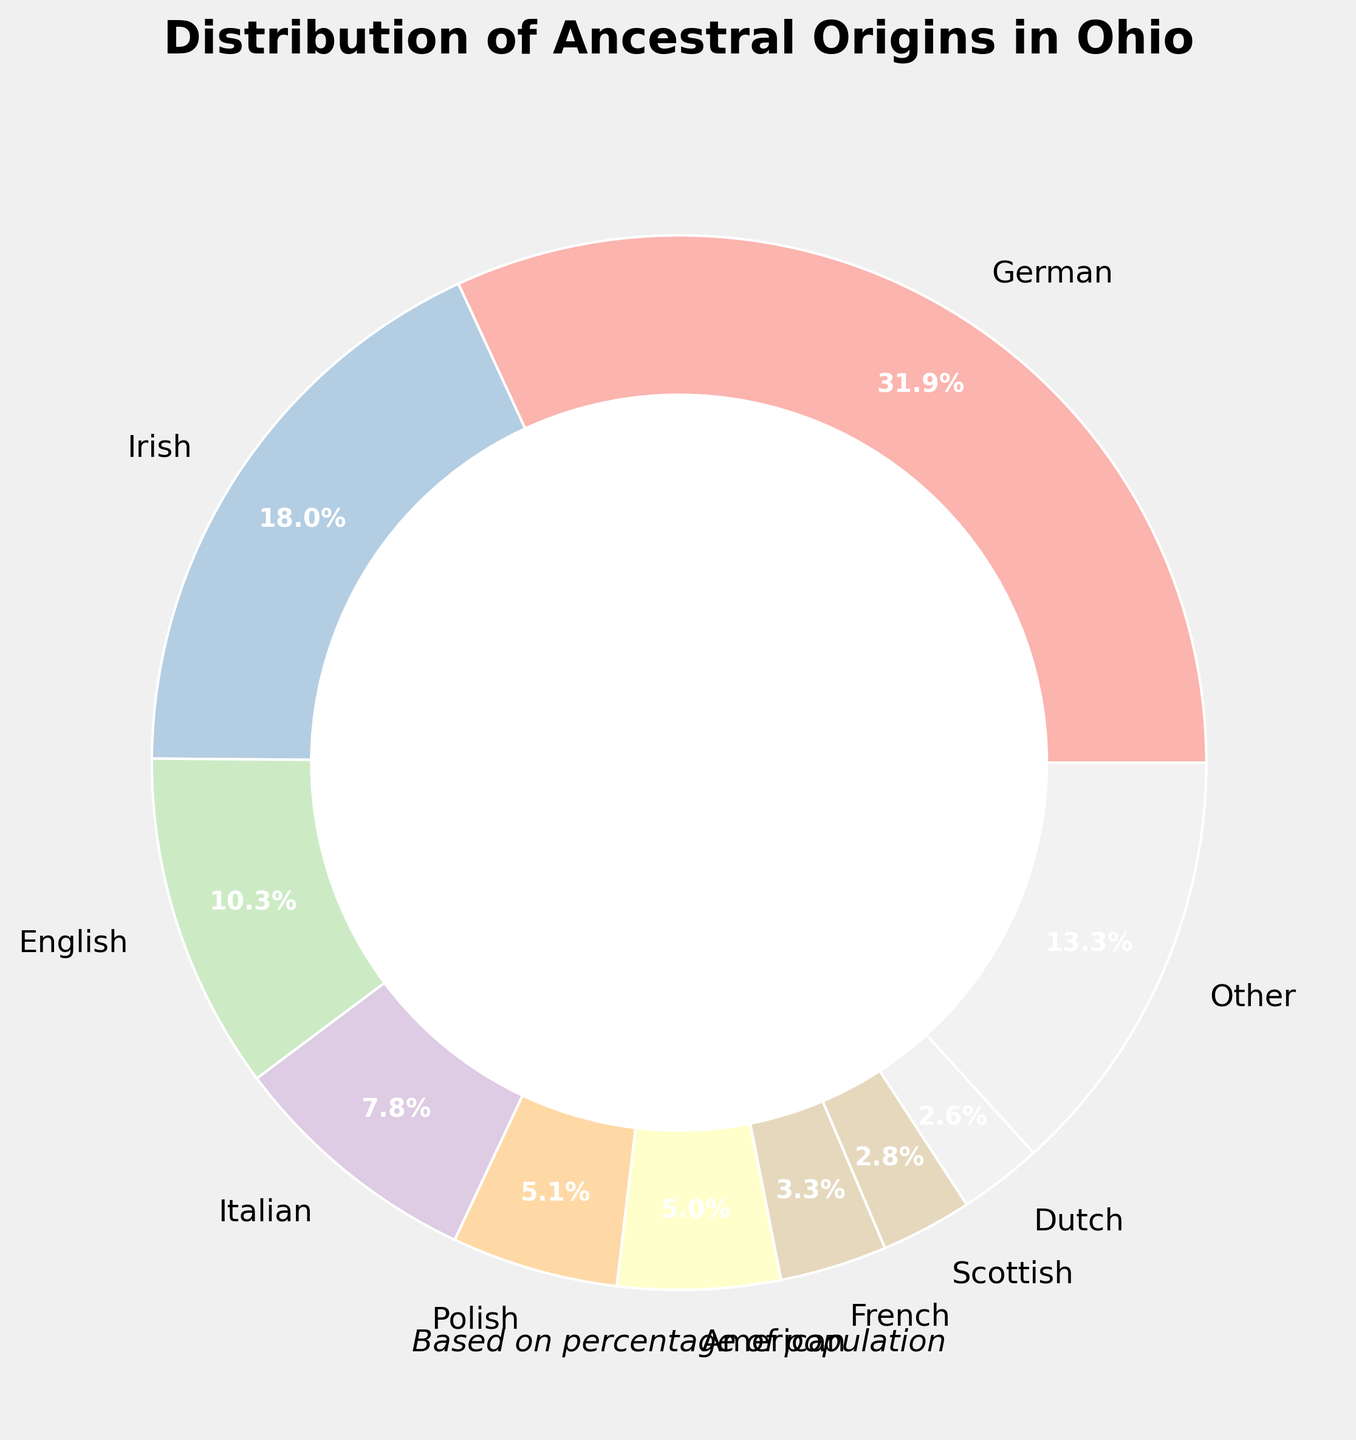What is the most common ancestral origin among Ohioans according to the chart? By observing the size of the pie slices, we can see which slice is the largest. In the chart, the largest slice represents German ancestry.
Answer: German What is the combined percentage of people with Italian and Polish ancestry? To find the combined percentage, we need to sum the individual percentages of Italian (6.4%) and Polish (4.2%) ancestry. Adding these together gives 6.4 + 4.2 = 10.6%.
Answer: 10.6% Which ancestry category has a smaller percentage: Hungarian or Welsh? By comparing the sizes of the slices labeled Hungarian (1.8%) and Welsh (1.5%), we see that the Welsh slice is smaller.
Answer: Welsh What is the approximate difference in percentage between those of Irish and English ancestries? To find the difference, subtract the smaller percentage (English, 8.5%) from the larger percentage (Irish, 14.8%). The difference is 14.8 - 8.5 = 6.3%.
Answer: 6.3% How many ancestral origins make up the "Other" category? The chart groups smaller percentages into an "Other" category. Ancestries below the 2.0% threshold are: Scottish (2.3%), Dutch (2.1%), Hungarian (1.8%), Welsh (1.5%), Scandinavian (1.4%), Czech (1.2%), Slovak (1.1%), Greek (0.9%), Ukrainian (0.8%), Swiss (0.7%), Croatian (0.6%), Slovenian (0.5%), Lithuanian (0.4%). Counting these gives 13 origins.
Answer: 13 What is the third most common ancestry based on percentage? By evaluating the sizes of the slices or the percentages, we can determine the ranking. The third largest slice shows English ancestry with 8.5%.
Answer: English If you combine the percentages of people of American and French ancestry, is the total greater than the percentage of those with Irish ancestry? First, sum the percentages of American (4.1%) and French (2.7%) ancestries, which gives 4.1 + 2.7 = 6.8%. Then compare this to the Irish percentage (14.8%). 6.8% is not greater than 14.8%.
Answer: No Which slice color on the chart represents the Scottish ancestry? By observing the slice labeled Scottish and noting its color, it’s the purple slice.
Answer: Purple What is the total percentage of ancestral origins that each individually contribute less than 1%? The chart shows several origins contributing less than 1%: Greek (0.9%), Ukrainian (0.8%), Swiss (0.7%), Croatian (0.6%), Slovenian (0.5%), Lithuanian (0.4%). Summing these gives 0.9 + 0.8 + 0.7 + 0.6 + 0.5 + 0.4 = 3.9%.
Answer: 3.9% 